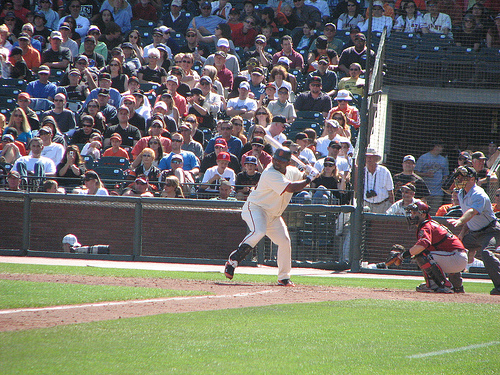How many umpires are in the photo? There is one umpire visible in the photo, standing in the typical position behind the catcher and the batter, ready to make calls on the pitches. 